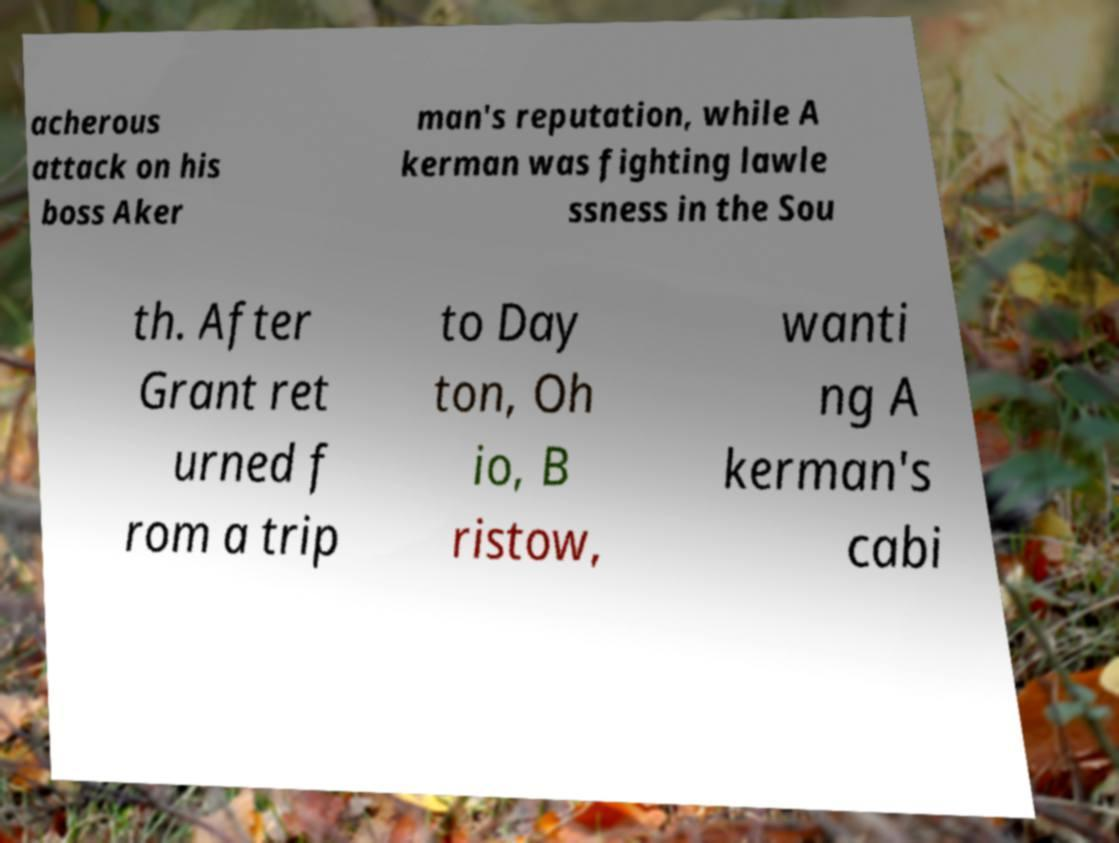Could you extract and type out the text from this image? acherous attack on his boss Aker man's reputation, while A kerman was fighting lawle ssness in the Sou th. After Grant ret urned f rom a trip to Day ton, Oh io, B ristow, wanti ng A kerman's cabi 